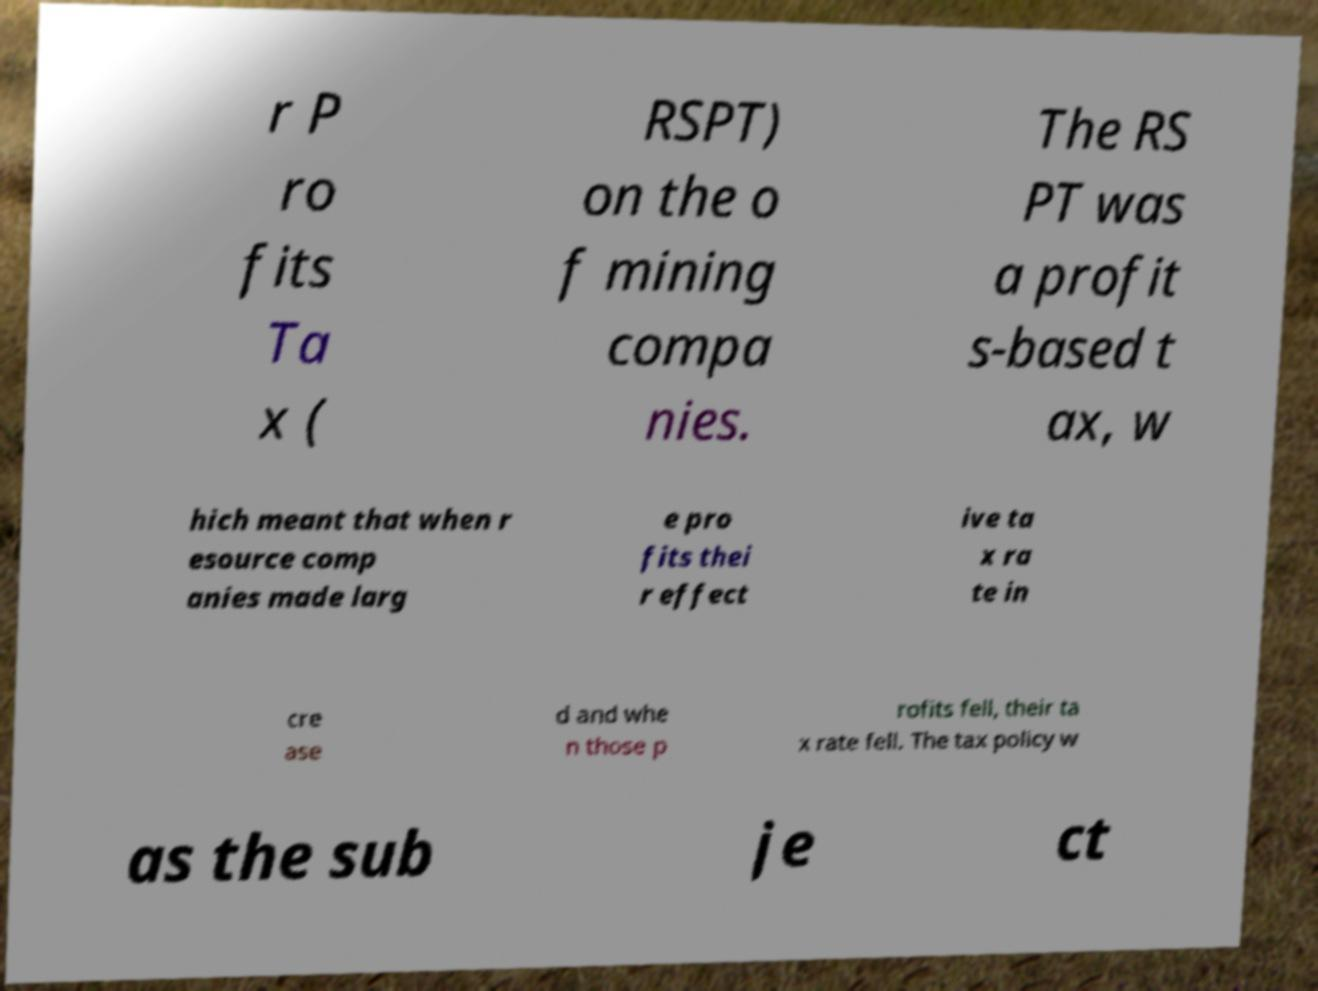Can you read and provide the text displayed in the image?This photo seems to have some interesting text. Can you extract and type it out for me? r P ro fits Ta x ( RSPT) on the o f mining compa nies. The RS PT was a profit s-based t ax, w hich meant that when r esource comp anies made larg e pro fits thei r effect ive ta x ra te in cre ase d and whe n those p rofits fell, their ta x rate fell. The tax policy w as the sub je ct 